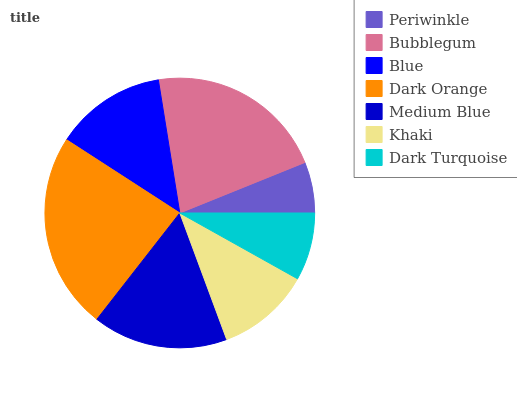Is Periwinkle the minimum?
Answer yes or no. Yes. Is Dark Orange the maximum?
Answer yes or no. Yes. Is Bubblegum the minimum?
Answer yes or no. No. Is Bubblegum the maximum?
Answer yes or no. No. Is Bubblegum greater than Periwinkle?
Answer yes or no. Yes. Is Periwinkle less than Bubblegum?
Answer yes or no. Yes. Is Periwinkle greater than Bubblegum?
Answer yes or no. No. Is Bubblegum less than Periwinkle?
Answer yes or no. No. Is Blue the high median?
Answer yes or no. Yes. Is Blue the low median?
Answer yes or no. Yes. Is Khaki the high median?
Answer yes or no. No. Is Dark Turquoise the low median?
Answer yes or no. No. 